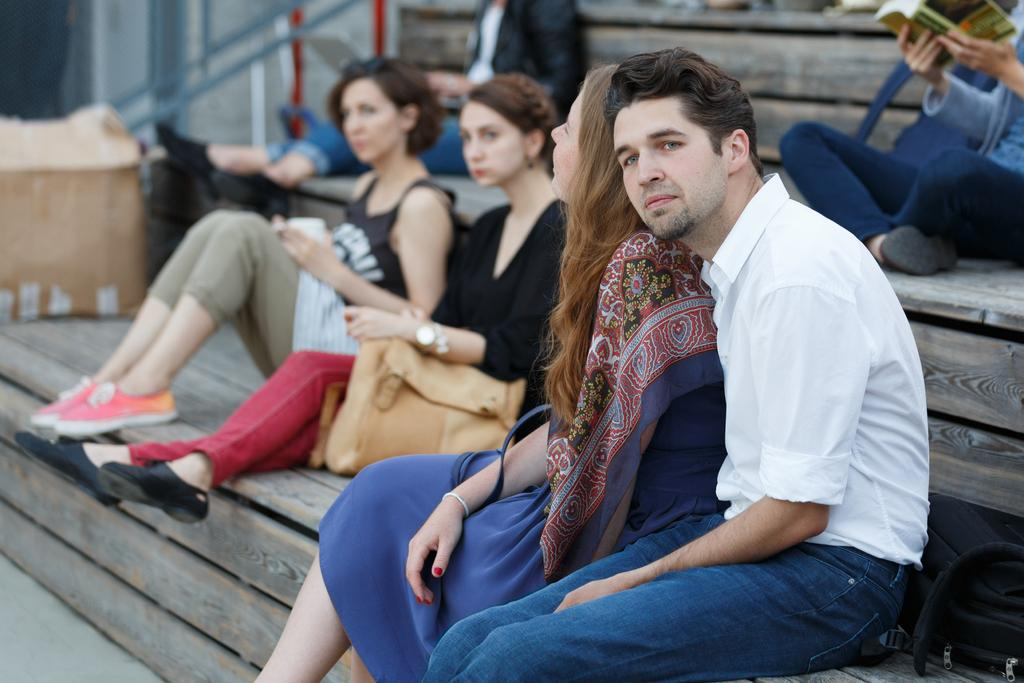What are the people sitting on in the image? The people are sitting on a wooden thing. Can you describe the actions of the individuals in the image? A person is holding a book on the right side, and another lady is holding a bag. How would you describe the background of the image? The background of the image is blurred. Where is the nest of quince located in the image? There is no nest or quince present in the image. Is there a ship visible in the image? No, there is no ship visible in the image. 